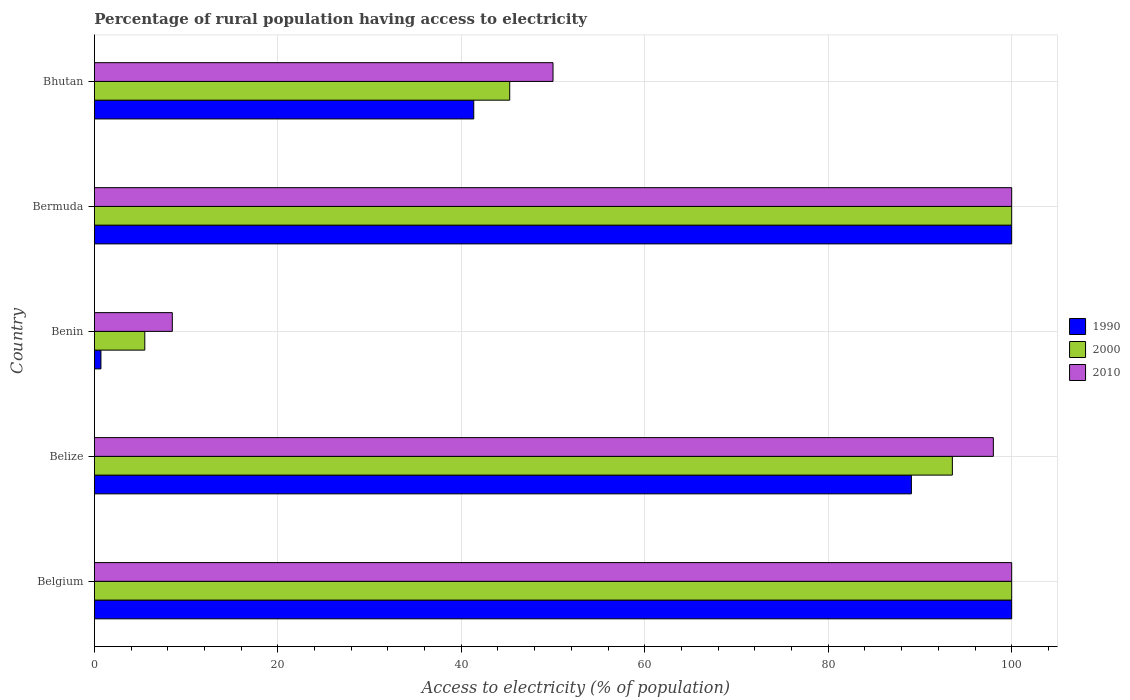How many different coloured bars are there?
Keep it short and to the point. 3. Are the number of bars on each tick of the Y-axis equal?
Offer a very short reply. Yes. What is the label of the 3rd group of bars from the top?
Ensure brevity in your answer.  Benin. What is the percentage of rural population having access to electricity in 1990 in Belgium?
Your answer should be compact. 100. In which country was the percentage of rural population having access to electricity in 2000 minimum?
Your answer should be compact. Benin. What is the total percentage of rural population having access to electricity in 2000 in the graph?
Ensure brevity in your answer.  344.31. What is the difference between the percentage of rural population having access to electricity in 2000 in Belgium and that in Bermuda?
Offer a very short reply. 0. What is the difference between the percentage of rural population having access to electricity in 2000 in Belize and the percentage of rural population having access to electricity in 2010 in Bhutan?
Your answer should be compact. 43.53. What is the average percentage of rural population having access to electricity in 2000 per country?
Your answer should be very brief. 68.86. Is the difference between the percentage of rural population having access to electricity in 2000 in Belgium and Benin greater than the difference between the percentage of rural population having access to electricity in 2010 in Belgium and Benin?
Provide a short and direct response. Yes. What is the difference between the highest and the lowest percentage of rural population having access to electricity in 2000?
Ensure brevity in your answer.  94.5. In how many countries, is the percentage of rural population having access to electricity in 1990 greater than the average percentage of rural population having access to electricity in 1990 taken over all countries?
Provide a succinct answer. 3. Is the sum of the percentage of rural population having access to electricity in 2000 in Benin and Bhutan greater than the maximum percentage of rural population having access to electricity in 2010 across all countries?
Your response must be concise. No. What does the 3rd bar from the top in Bermuda represents?
Ensure brevity in your answer.  1990. Is it the case that in every country, the sum of the percentage of rural population having access to electricity in 2010 and percentage of rural population having access to electricity in 2000 is greater than the percentage of rural population having access to electricity in 1990?
Offer a very short reply. Yes. How many bars are there?
Your answer should be very brief. 15. Does the graph contain any zero values?
Provide a succinct answer. No. Does the graph contain grids?
Make the answer very short. Yes. Where does the legend appear in the graph?
Your answer should be very brief. Center right. How many legend labels are there?
Ensure brevity in your answer.  3. What is the title of the graph?
Your answer should be compact. Percentage of rural population having access to electricity. Does "1972" appear as one of the legend labels in the graph?
Provide a succinct answer. No. What is the label or title of the X-axis?
Your response must be concise. Access to electricity (% of population). What is the Access to electricity (% of population) of 1990 in Belgium?
Provide a succinct answer. 100. What is the Access to electricity (% of population) in 2010 in Belgium?
Your response must be concise. 100. What is the Access to electricity (% of population) in 1990 in Belize?
Your response must be concise. 89.07. What is the Access to electricity (% of population) in 2000 in Belize?
Your answer should be very brief. 93.53. What is the Access to electricity (% of population) of 2010 in Belize?
Your answer should be compact. 98. What is the Access to electricity (% of population) in 1990 in Benin?
Offer a terse response. 0.72. What is the Access to electricity (% of population) in 1990 in Bermuda?
Provide a short and direct response. 100. What is the Access to electricity (% of population) of 1990 in Bhutan?
Your response must be concise. 41.36. What is the Access to electricity (% of population) of 2000 in Bhutan?
Provide a short and direct response. 45.28. Across all countries, what is the maximum Access to electricity (% of population) in 2000?
Ensure brevity in your answer.  100. Across all countries, what is the minimum Access to electricity (% of population) of 1990?
Provide a short and direct response. 0.72. Across all countries, what is the minimum Access to electricity (% of population) of 2000?
Ensure brevity in your answer.  5.5. Across all countries, what is the minimum Access to electricity (% of population) of 2010?
Your response must be concise. 8.5. What is the total Access to electricity (% of population) in 1990 in the graph?
Your answer should be very brief. 331.15. What is the total Access to electricity (% of population) of 2000 in the graph?
Provide a short and direct response. 344.31. What is the total Access to electricity (% of population) in 2010 in the graph?
Give a very brief answer. 356.5. What is the difference between the Access to electricity (% of population) in 1990 in Belgium and that in Belize?
Your answer should be very brief. 10.93. What is the difference between the Access to electricity (% of population) of 2000 in Belgium and that in Belize?
Provide a short and direct response. 6.47. What is the difference between the Access to electricity (% of population) of 2010 in Belgium and that in Belize?
Your answer should be very brief. 2. What is the difference between the Access to electricity (% of population) in 1990 in Belgium and that in Benin?
Give a very brief answer. 99.28. What is the difference between the Access to electricity (% of population) of 2000 in Belgium and that in Benin?
Give a very brief answer. 94.5. What is the difference between the Access to electricity (% of population) in 2010 in Belgium and that in Benin?
Give a very brief answer. 91.5. What is the difference between the Access to electricity (% of population) of 2000 in Belgium and that in Bermuda?
Ensure brevity in your answer.  0. What is the difference between the Access to electricity (% of population) of 2010 in Belgium and that in Bermuda?
Offer a very short reply. 0. What is the difference between the Access to electricity (% of population) in 1990 in Belgium and that in Bhutan?
Provide a short and direct response. 58.64. What is the difference between the Access to electricity (% of population) of 2000 in Belgium and that in Bhutan?
Provide a succinct answer. 54.72. What is the difference between the Access to electricity (% of population) in 1990 in Belize and that in Benin?
Ensure brevity in your answer.  88.35. What is the difference between the Access to electricity (% of population) of 2000 in Belize and that in Benin?
Your answer should be very brief. 88.03. What is the difference between the Access to electricity (% of population) in 2010 in Belize and that in Benin?
Your answer should be compact. 89.5. What is the difference between the Access to electricity (% of population) in 1990 in Belize and that in Bermuda?
Ensure brevity in your answer.  -10.93. What is the difference between the Access to electricity (% of population) of 2000 in Belize and that in Bermuda?
Provide a short and direct response. -6.47. What is the difference between the Access to electricity (% of population) in 1990 in Belize and that in Bhutan?
Your answer should be very brief. 47.71. What is the difference between the Access to electricity (% of population) of 2000 in Belize and that in Bhutan?
Your response must be concise. 48.25. What is the difference between the Access to electricity (% of population) in 2010 in Belize and that in Bhutan?
Offer a terse response. 48. What is the difference between the Access to electricity (% of population) in 1990 in Benin and that in Bermuda?
Your answer should be very brief. -99.28. What is the difference between the Access to electricity (% of population) in 2000 in Benin and that in Bermuda?
Provide a short and direct response. -94.5. What is the difference between the Access to electricity (% of population) in 2010 in Benin and that in Bermuda?
Ensure brevity in your answer.  -91.5. What is the difference between the Access to electricity (% of population) of 1990 in Benin and that in Bhutan?
Provide a short and direct response. -40.64. What is the difference between the Access to electricity (% of population) in 2000 in Benin and that in Bhutan?
Your answer should be very brief. -39.78. What is the difference between the Access to electricity (% of population) in 2010 in Benin and that in Bhutan?
Offer a very short reply. -41.5. What is the difference between the Access to electricity (% of population) of 1990 in Bermuda and that in Bhutan?
Provide a succinct answer. 58.64. What is the difference between the Access to electricity (% of population) in 2000 in Bermuda and that in Bhutan?
Offer a terse response. 54.72. What is the difference between the Access to electricity (% of population) of 2010 in Bermuda and that in Bhutan?
Give a very brief answer. 50. What is the difference between the Access to electricity (% of population) in 1990 in Belgium and the Access to electricity (% of population) in 2000 in Belize?
Give a very brief answer. 6.47. What is the difference between the Access to electricity (% of population) of 1990 in Belgium and the Access to electricity (% of population) of 2010 in Belize?
Give a very brief answer. 2. What is the difference between the Access to electricity (% of population) of 2000 in Belgium and the Access to electricity (% of population) of 2010 in Belize?
Your answer should be very brief. 2. What is the difference between the Access to electricity (% of population) in 1990 in Belgium and the Access to electricity (% of population) in 2000 in Benin?
Offer a very short reply. 94.5. What is the difference between the Access to electricity (% of population) of 1990 in Belgium and the Access to electricity (% of population) of 2010 in Benin?
Provide a succinct answer. 91.5. What is the difference between the Access to electricity (% of population) of 2000 in Belgium and the Access to electricity (% of population) of 2010 in Benin?
Provide a short and direct response. 91.5. What is the difference between the Access to electricity (% of population) of 1990 in Belgium and the Access to electricity (% of population) of 2000 in Bermuda?
Offer a very short reply. 0. What is the difference between the Access to electricity (% of population) in 1990 in Belgium and the Access to electricity (% of population) in 2010 in Bermuda?
Offer a terse response. 0. What is the difference between the Access to electricity (% of population) of 2000 in Belgium and the Access to electricity (% of population) of 2010 in Bermuda?
Your answer should be very brief. 0. What is the difference between the Access to electricity (% of population) of 1990 in Belgium and the Access to electricity (% of population) of 2000 in Bhutan?
Your response must be concise. 54.72. What is the difference between the Access to electricity (% of population) of 1990 in Belgium and the Access to electricity (% of population) of 2010 in Bhutan?
Your answer should be compact. 50. What is the difference between the Access to electricity (% of population) in 2000 in Belgium and the Access to electricity (% of population) in 2010 in Bhutan?
Keep it short and to the point. 50. What is the difference between the Access to electricity (% of population) of 1990 in Belize and the Access to electricity (% of population) of 2000 in Benin?
Provide a short and direct response. 83.57. What is the difference between the Access to electricity (% of population) in 1990 in Belize and the Access to electricity (% of population) in 2010 in Benin?
Your answer should be very brief. 80.57. What is the difference between the Access to electricity (% of population) in 2000 in Belize and the Access to electricity (% of population) in 2010 in Benin?
Your response must be concise. 85.03. What is the difference between the Access to electricity (% of population) in 1990 in Belize and the Access to electricity (% of population) in 2000 in Bermuda?
Keep it short and to the point. -10.93. What is the difference between the Access to electricity (% of population) in 1990 in Belize and the Access to electricity (% of population) in 2010 in Bermuda?
Keep it short and to the point. -10.93. What is the difference between the Access to electricity (% of population) in 2000 in Belize and the Access to electricity (% of population) in 2010 in Bermuda?
Make the answer very short. -6.47. What is the difference between the Access to electricity (% of population) in 1990 in Belize and the Access to electricity (% of population) in 2000 in Bhutan?
Give a very brief answer. 43.79. What is the difference between the Access to electricity (% of population) of 1990 in Belize and the Access to electricity (% of population) of 2010 in Bhutan?
Keep it short and to the point. 39.07. What is the difference between the Access to electricity (% of population) of 2000 in Belize and the Access to electricity (% of population) of 2010 in Bhutan?
Ensure brevity in your answer.  43.53. What is the difference between the Access to electricity (% of population) of 1990 in Benin and the Access to electricity (% of population) of 2000 in Bermuda?
Your answer should be very brief. -99.28. What is the difference between the Access to electricity (% of population) in 1990 in Benin and the Access to electricity (% of population) in 2010 in Bermuda?
Give a very brief answer. -99.28. What is the difference between the Access to electricity (% of population) in 2000 in Benin and the Access to electricity (% of population) in 2010 in Bermuda?
Offer a terse response. -94.5. What is the difference between the Access to electricity (% of population) of 1990 in Benin and the Access to electricity (% of population) of 2000 in Bhutan?
Make the answer very short. -44.56. What is the difference between the Access to electricity (% of population) of 1990 in Benin and the Access to electricity (% of population) of 2010 in Bhutan?
Offer a very short reply. -49.28. What is the difference between the Access to electricity (% of population) of 2000 in Benin and the Access to electricity (% of population) of 2010 in Bhutan?
Your answer should be very brief. -44.5. What is the difference between the Access to electricity (% of population) of 1990 in Bermuda and the Access to electricity (% of population) of 2000 in Bhutan?
Ensure brevity in your answer.  54.72. What is the difference between the Access to electricity (% of population) in 1990 in Bermuda and the Access to electricity (% of population) in 2010 in Bhutan?
Your response must be concise. 50. What is the difference between the Access to electricity (% of population) of 2000 in Bermuda and the Access to electricity (% of population) of 2010 in Bhutan?
Your answer should be very brief. 50. What is the average Access to electricity (% of population) of 1990 per country?
Provide a succinct answer. 66.23. What is the average Access to electricity (% of population) of 2000 per country?
Your answer should be very brief. 68.86. What is the average Access to electricity (% of population) of 2010 per country?
Keep it short and to the point. 71.3. What is the difference between the Access to electricity (% of population) of 2000 and Access to electricity (% of population) of 2010 in Belgium?
Keep it short and to the point. 0. What is the difference between the Access to electricity (% of population) of 1990 and Access to electricity (% of population) of 2000 in Belize?
Your response must be concise. -4.47. What is the difference between the Access to electricity (% of population) in 1990 and Access to electricity (% of population) in 2010 in Belize?
Ensure brevity in your answer.  -8.93. What is the difference between the Access to electricity (% of population) of 2000 and Access to electricity (% of population) of 2010 in Belize?
Your answer should be compact. -4.47. What is the difference between the Access to electricity (% of population) in 1990 and Access to electricity (% of population) in 2000 in Benin?
Make the answer very short. -4.78. What is the difference between the Access to electricity (% of population) of 1990 and Access to electricity (% of population) of 2010 in Benin?
Ensure brevity in your answer.  -7.78. What is the difference between the Access to electricity (% of population) of 1990 and Access to electricity (% of population) of 2000 in Bermuda?
Ensure brevity in your answer.  0. What is the difference between the Access to electricity (% of population) in 1990 and Access to electricity (% of population) in 2000 in Bhutan?
Provide a short and direct response. -3.92. What is the difference between the Access to electricity (% of population) in 1990 and Access to electricity (% of population) in 2010 in Bhutan?
Provide a succinct answer. -8.64. What is the difference between the Access to electricity (% of population) in 2000 and Access to electricity (% of population) in 2010 in Bhutan?
Your answer should be compact. -4.72. What is the ratio of the Access to electricity (% of population) in 1990 in Belgium to that in Belize?
Keep it short and to the point. 1.12. What is the ratio of the Access to electricity (% of population) in 2000 in Belgium to that in Belize?
Provide a short and direct response. 1.07. What is the ratio of the Access to electricity (% of population) of 2010 in Belgium to that in Belize?
Keep it short and to the point. 1.02. What is the ratio of the Access to electricity (% of population) of 1990 in Belgium to that in Benin?
Your answer should be compact. 138.93. What is the ratio of the Access to electricity (% of population) of 2000 in Belgium to that in Benin?
Keep it short and to the point. 18.18. What is the ratio of the Access to electricity (% of population) of 2010 in Belgium to that in Benin?
Provide a succinct answer. 11.76. What is the ratio of the Access to electricity (% of population) of 2010 in Belgium to that in Bermuda?
Give a very brief answer. 1. What is the ratio of the Access to electricity (% of population) of 1990 in Belgium to that in Bhutan?
Offer a terse response. 2.42. What is the ratio of the Access to electricity (% of population) of 2000 in Belgium to that in Bhutan?
Ensure brevity in your answer.  2.21. What is the ratio of the Access to electricity (% of population) in 2010 in Belgium to that in Bhutan?
Offer a very short reply. 2. What is the ratio of the Access to electricity (% of population) in 1990 in Belize to that in Benin?
Your response must be concise. 123.74. What is the ratio of the Access to electricity (% of population) of 2000 in Belize to that in Benin?
Ensure brevity in your answer.  17.01. What is the ratio of the Access to electricity (% of population) of 2010 in Belize to that in Benin?
Ensure brevity in your answer.  11.53. What is the ratio of the Access to electricity (% of population) of 1990 in Belize to that in Bermuda?
Your response must be concise. 0.89. What is the ratio of the Access to electricity (% of population) in 2000 in Belize to that in Bermuda?
Offer a terse response. 0.94. What is the ratio of the Access to electricity (% of population) of 2010 in Belize to that in Bermuda?
Provide a short and direct response. 0.98. What is the ratio of the Access to electricity (% of population) of 1990 in Belize to that in Bhutan?
Provide a succinct answer. 2.15. What is the ratio of the Access to electricity (% of population) of 2000 in Belize to that in Bhutan?
Provide a succinct answer. 2.07. What is the ratio of the Access to electricity (% of population) of 2010 in Belize to that in Bhutan?
Your answer should be very brief. 1.96. What is the ratio of the Access to electricity (% of population) of 1990 in Benin to that in Bermuda?
Keep it short and to the point. 0.01. What is the ratio of the Access to electricity (% of population) in 2000 in Benin to that in Bermuda?
Keep it short and to the point. 0.06. What is the ratio of the Access to electricity (% of population) in 2010 in Benin to that in Bermuda?
Give a very brief answer. 0.09. What is the ratio of the Access to electricity (% of population) in 1990 in Benin to that in Bhutan?
Your answer should be very brief. 0.02. What is the ratio of the Access to electricity (% of population) of 2000 in Benin to that in Bhutan?
Your answer should be compact. 0.12. What is the ratio of the Access to electricity (% of population) of 2010 in Benin to that in Bhutan?
Offer a very short reply. 0.17. What is the ratio of the Access to electricity (% of population) of 1990 in Bermuda to that in Bhutan?
Provide a short and direct response. 2.42. What is the ratio of the Access to electricity (% of population) of 2000 in Bermuda to that in Bhutan?
Provide a succinct answer. 2.21. What is the ratio of the Access to electricity (% of population) in 2010 in Bermuda to that in Bhutan?
Provide a succinct answer. 2. What is the difference between the highest and the second highest Access to electricity (% of population) in 1990?
Make the answer very short. 0. What is the difference between the highest and the second highest Access to electricity (% of population) in 2000?
Provide a short and direct response. 0. What is the difference between the highest and the lowest Access to electricity (% of population) in 1990?
Your response must be concise. 99.28. What is the difference between the highest and the lowest Access to electricity (% of population) of 2000?
Your response must be concise. 94.5. What is the difference between the highest and the lowest Access to electricity (% of population) of 2010?
Provide a succinct answer. 91.5. 